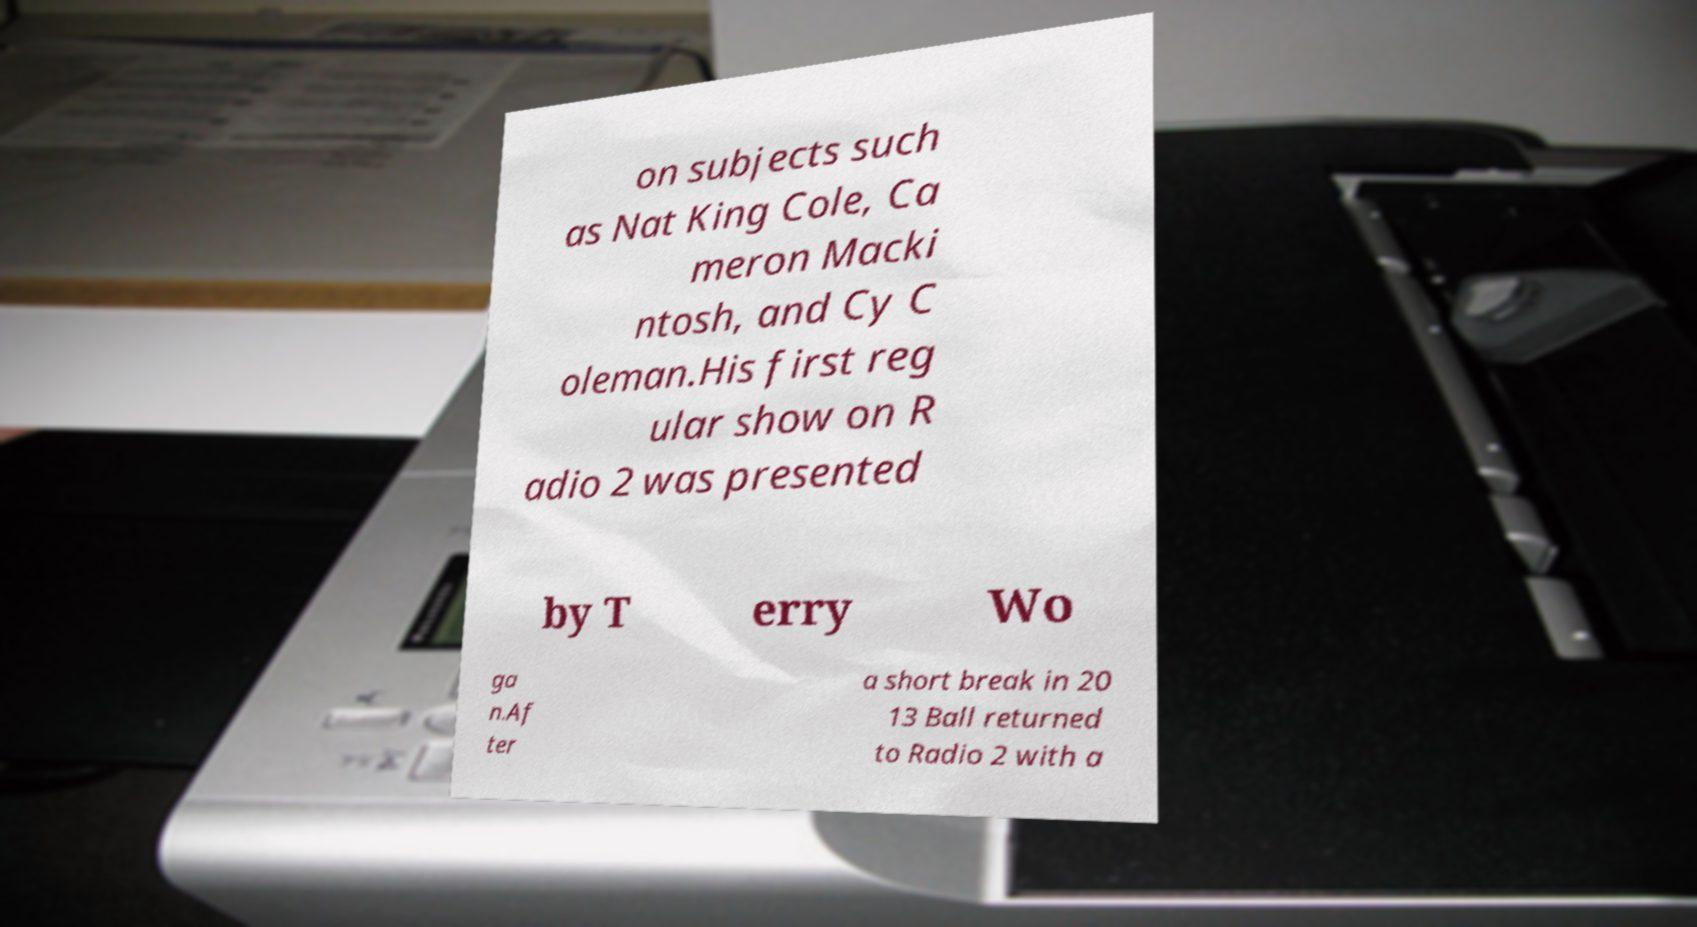Could you extract and type out the text from this image? on subjects such as Nat King Cole, Ca meron Macki ntosh, and Cy C oleman.His first reg ular show on R adio 2 was presented by T erry Wo ga n.Af ter a short break in 20 13 Ball returned to Radio 2 with a 